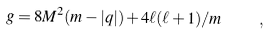<formula> <loc_0><loc_0><loc_500><loc_500>g = 8 M ^ { 2 } ( m - | q | ) + 4 \ell ( \ell + 1 ) / m \quad ,</formula> 